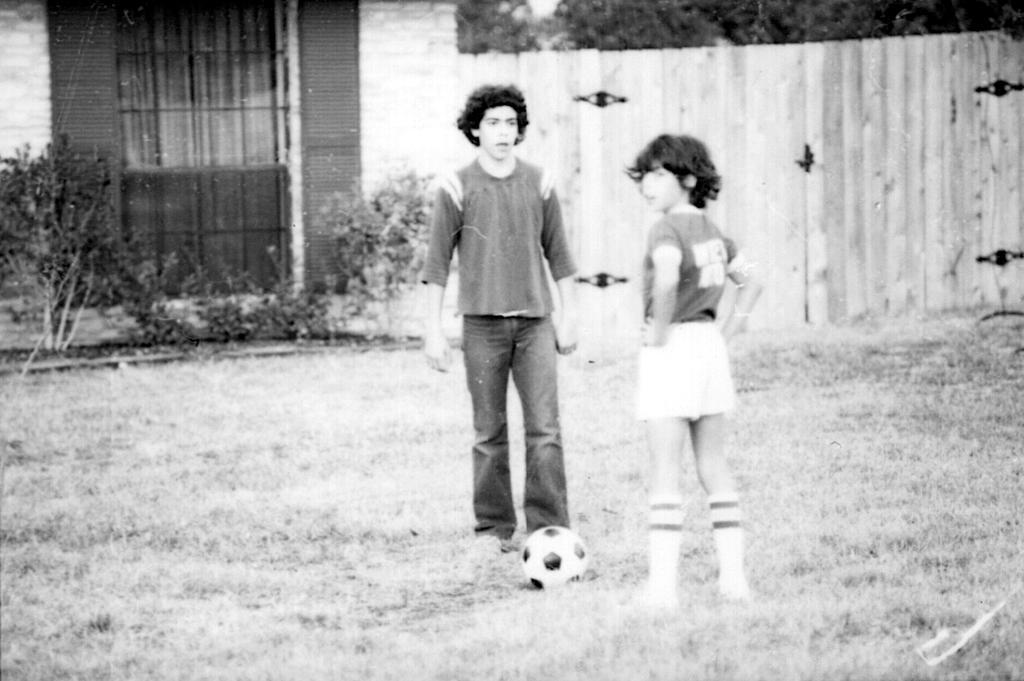Could you give a brief overview of what you see in this image? This picture shows couple of human standing and we see a football on the ground and we see a house, plants and grass on the ground and we see trees and a wooden fence. 